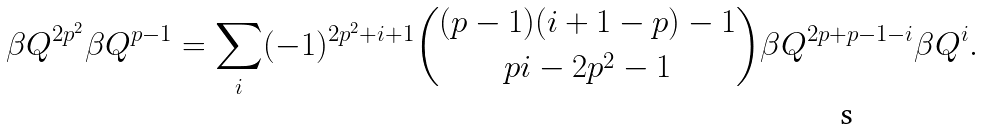<formula> <loc_0><loc_0><loc_500><loc_500>\beta Q ^ { 2 p ^ { 2 } } \beta Q ^ { p - 1 } = \sum _ { i } ( - 1 ) ^ { 2 p ^ { 2 } + i + 1 } \binom { ( p - 1 ) ( i + 1 - p ) - 1 } { p i - 2 p ^ { 2 } - 1 } \beta Q ^ { 2 p + p - 1 - i } \beta Q ^ { i } .</formula> 